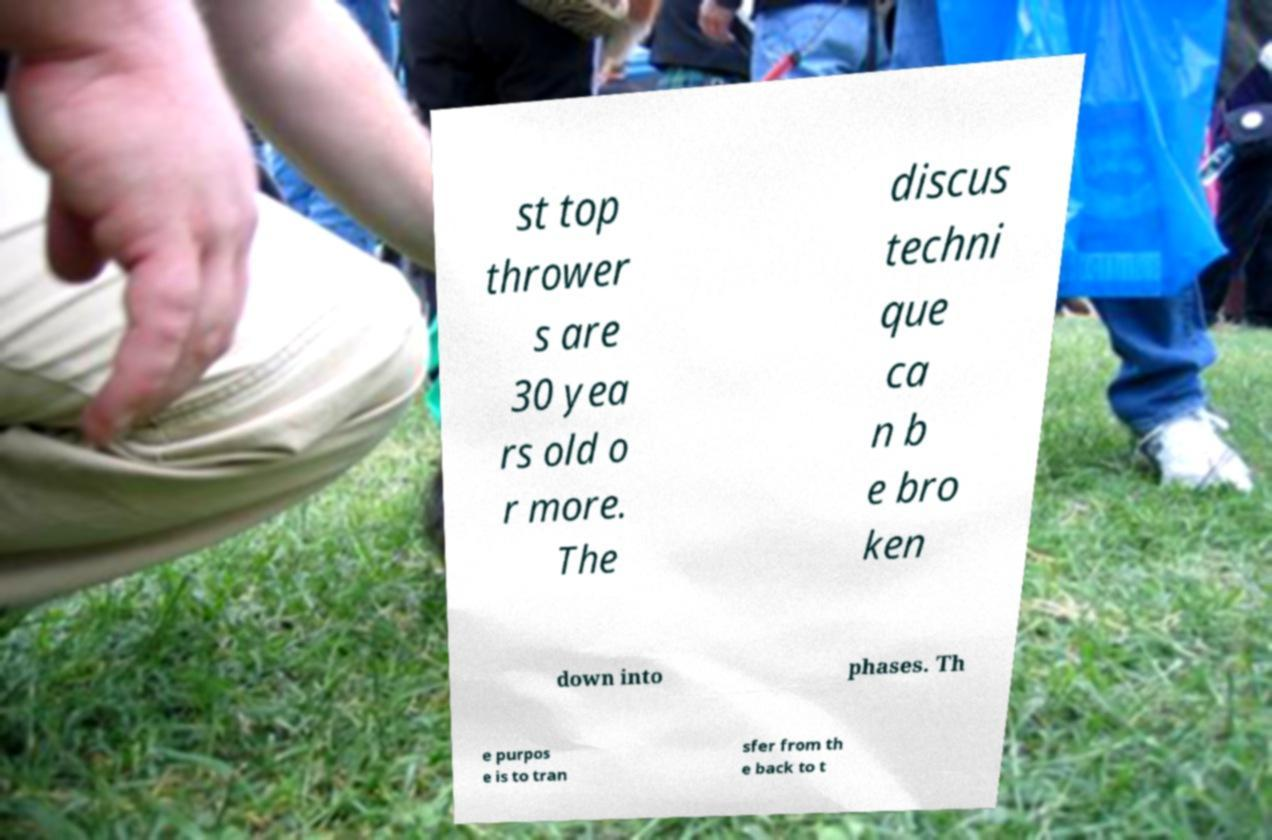Can you accurately transcribe the text from the provided image for me? st top thrower s are 30 yea rs old o r more. The discus techni que ca n b e bro ken down into phases. Th e purpos e is to tran sfer from th e back to t 